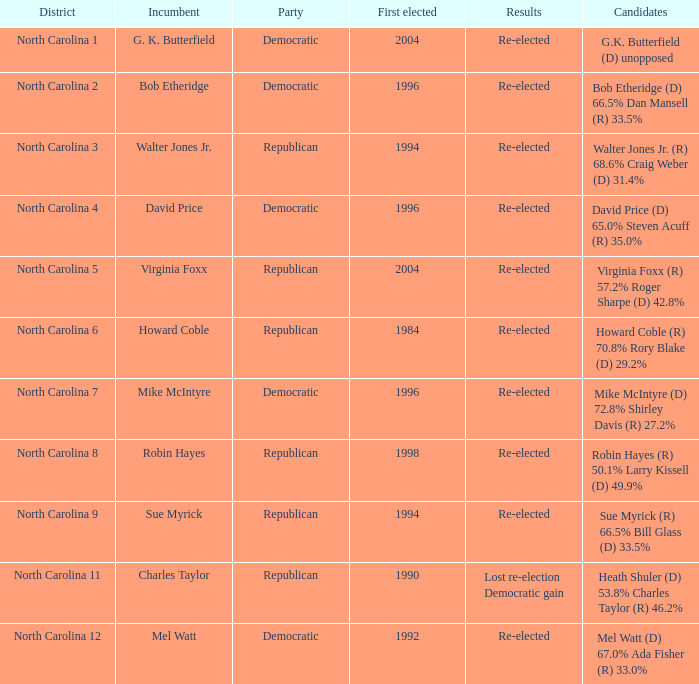How many times did Robin Hayes run? 1.0. 